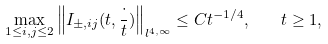Convert formula to latex. <formula><loc_0><loc_0><loc_500><loc_500>\max _ { 1 \leq i , j \leq 2 } \left \| I _ { \pm , i j } ( t , \frac { \cdot } { t } ) \right \| _ { l ^ { 4 , \infty } } \leq C t ^ { - 1 / 4 } , \quad t \geq 1 ,</formula> 